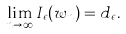Convert formula to latex. <formula><loc_0><loc_0><loc_500><loc_500>\lim _ { n \to \infty } I _ { \epsilon } ( w _ { n } ) = d _ { \epsilon } .</formula> 